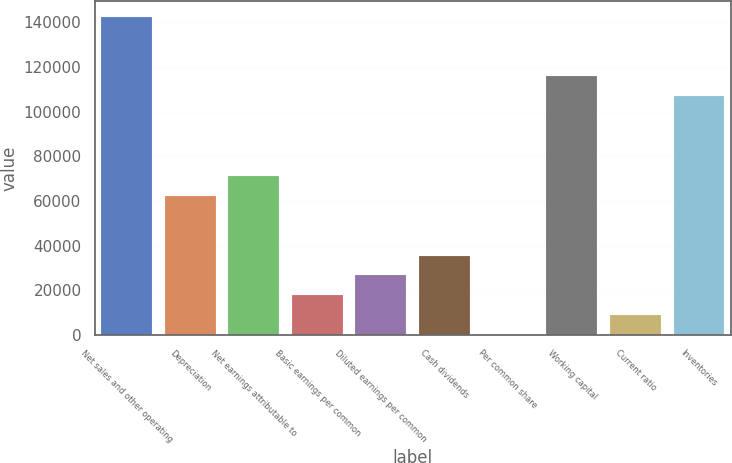Convert chart. <chart><loc_0><loc_0><loc_500><loc_500><bar_chart><fcel>Net sales and other operating<fcel>Depreciation<fcel>Net earnings attributable to<fcel>Basic earnings per common<fcel>Diluted earnings per common<fcel>Cash dividends<fcel>Per common share<fcel>Working capital<fcel>Current ratio<fcel>Inventories<nl><fcel>142460<fcel>62326.8<fcel>71230.5<fcel>17808.2<fcel>26711.9<fcel>35615.6<fcel>0.69<fcel>115749<fcel>8904.42<fcel>106845<nl></chart> 